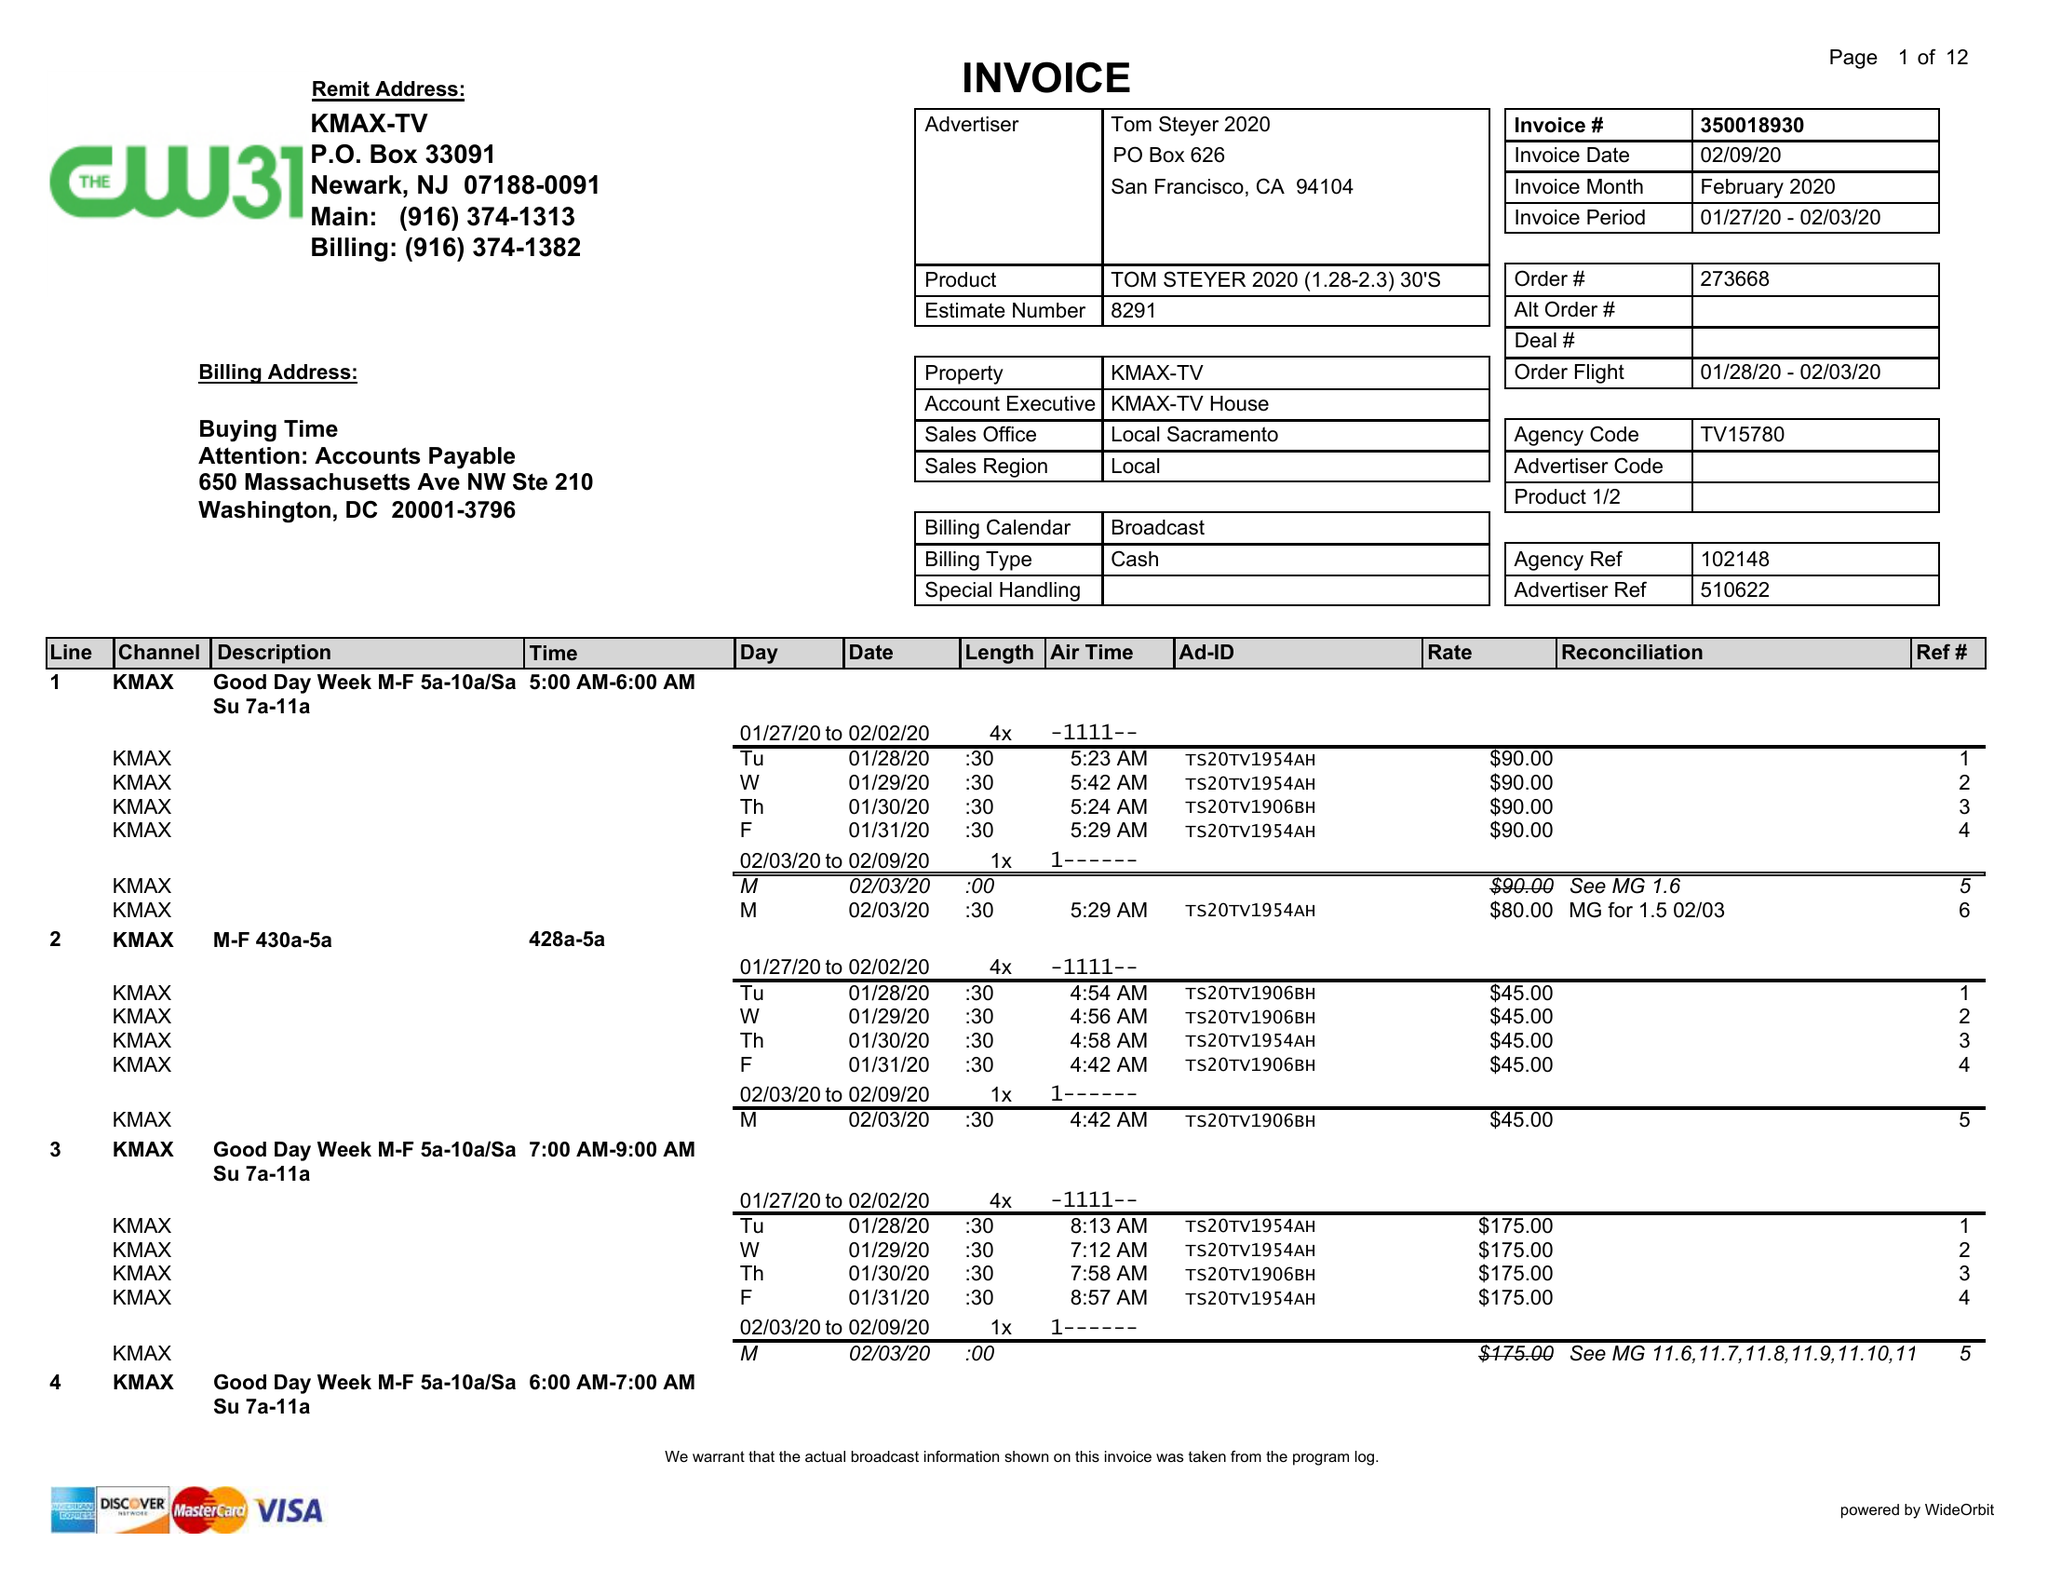What is the value for the flight_to?
Answer the question using a single word or phrase. 02/03/20 